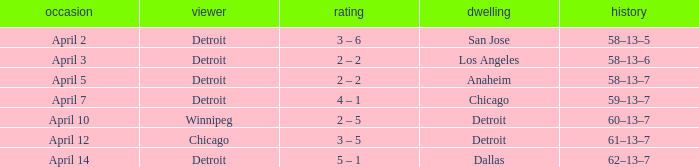What is the date of the game that had a visitor of Chicago? April 12. 